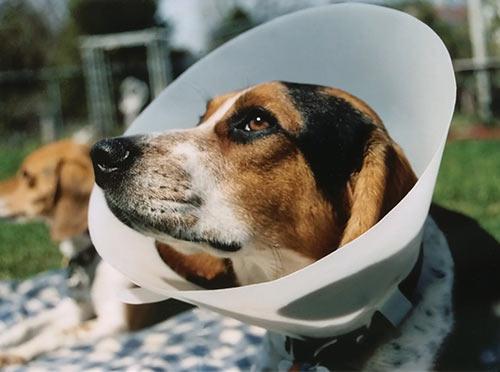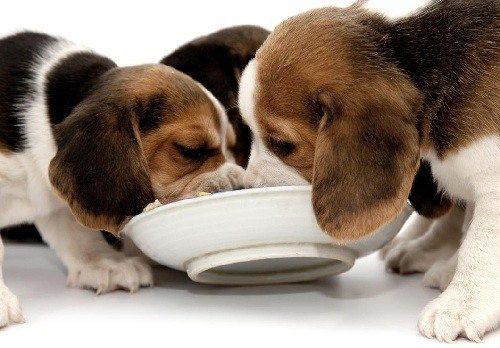The first image is the image on the left, the second image is the image on the right. For the images displayed, is the sentence "At least one beagle is eating out of a bowl." factually correct? Answer yes or no. Yes. The first image is the image on the left, the second image is the image on the right. For the images shown, is this caption "An image shows at least one beagle dog eating from a bowl." true? Answer yes or no. Yes. 